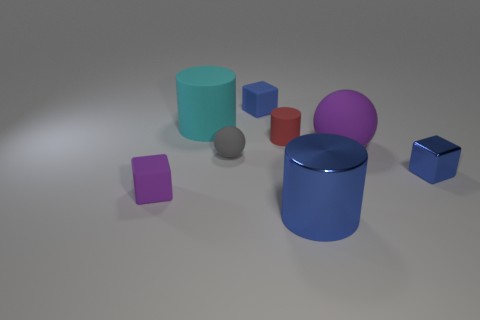Subtract all purple cylinders. Subtract all gray cubes. How many cylinders are left? 3 Add 1 shiny spheres. How many objects exist? 9 Subtract all cylinders. How many objects are left? 5 Add 7 yellow cylinders. How many yellow cylinders exist? 7 Subtract 1 blue cylinders. How many objects are left? 7 Subtract all large cyan rubber things. Subtract all matte objects. How many objects are left? 1 Add 1 large cylinders. How many large cylinders are left? 3 